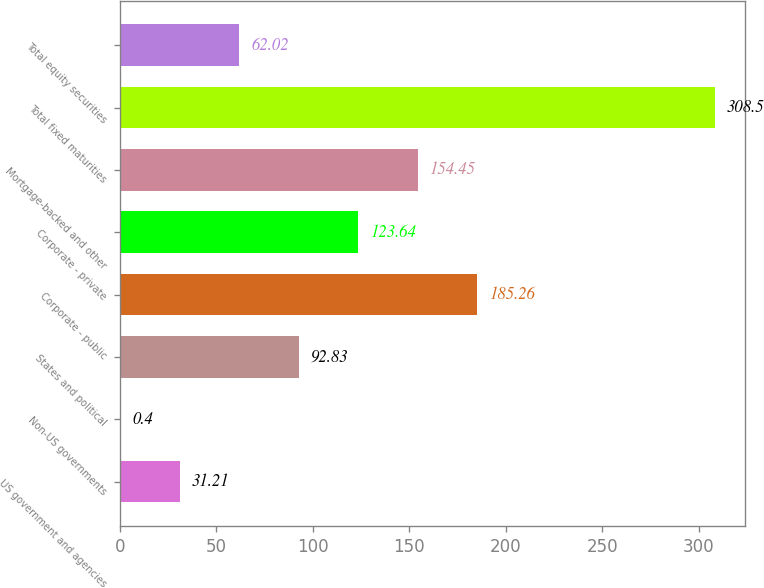Convert chart. <chart><loc_0><loc_0><loc_500><loc_500><bar_chart><fcel>US government and agencies<fcel>Non-US governments<fcel>States and political<fcel>Corporate - public<fcel>Corporate - private<fcel>Mortgage-backed and other<fcel>Total fixed maturities<fcel>Total equity securities<nl><fcel>31.21<fcel>0.4<fcel>92.83<fcel>185.26<fcel>123.64<fcel>154.45<fcel>308.5<fcel>62.02<nl></chart> 